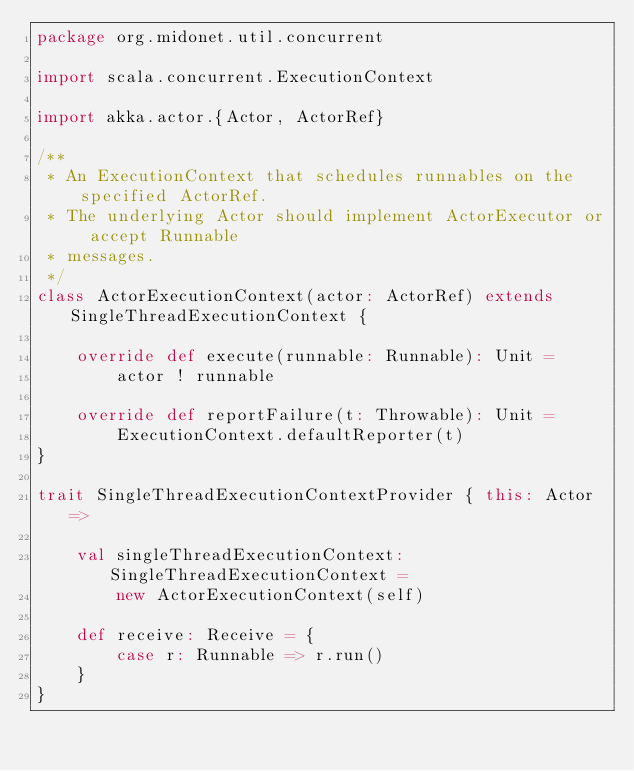<code> <loc_0><loc_0><loc_500><loc_500><_Scala_>package org.midonet.util.concurrent

import scala.concurrent.ExecutionContext

import akka.actor.{Actor, ActorRef}

/**
 * An ExecutionContext that schedules runnables on the specified ActorRef.
 * The underlying Actor should implement ActorExecutor or accept Runnable
 * messages.
 */
class ActorExecutionContext(actor: ActorRef) extends SingleThreadExecutionContext {

    override def execute(runnable: Runnable): Unit =
        actor ! runnable

    override def reportFailure(t: Throwable): Unit =
        ExecutionContext.defaultReporter(t)
}

trait SingleThreadExecutionContextProvider { this: Actor =>

    val singleThreadExecutionContext: SingleThreadExecutionContext =
        new ActorExecutionContext(self)

    def receive: Receive = {
        case r: Runnable => r.run()
    }
}
</code> 